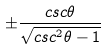Convert formula to latex. <formula><loc_0><loc_0><loc_500><loc_500>\pm \frac { c s c \theta } { \sqrt { c s c ^ { 2 } \theta - 1 } }</formula> 